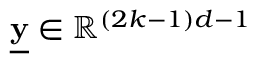<formula> <loc_0><loc_0><loc_500><loc_500>\underline { y } \in \mathbb { R } ^ { ( 2 k - 1 ) d - 1 }</formula> 